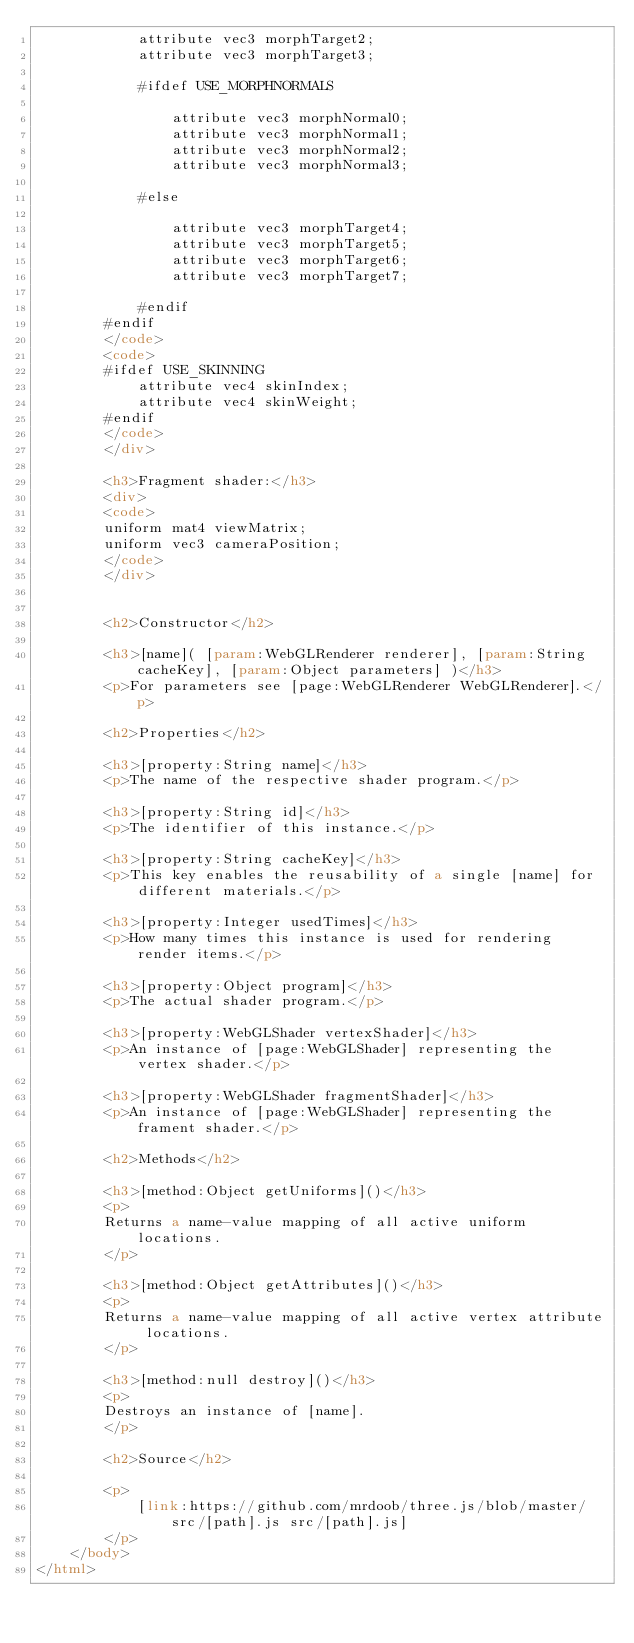<code> <loc_0><loc_0><loc_500><loc_500><_HTML_>			attribute vec3 morphTarget2;
			attribute vec3 morphTarget3;

			#ifdef USE_MORPHNORMALS

				attribute vec3 morphNormal0;
				attribute vec3 morphNormal1;
				attribute vec3 morphNormal2;
				attribute vec3 morphNormal3;

			#else

				attribute vec3 morphTarget4;
				attribute vec3 morphTarget5;
				attribute vec3 morphTarget6;
				attribute vec3 morphTarget7;

			#endif
		#endif
		</code>
		<code>
		#ifdef USE_SKINNING
			attribute vec4 skinIndex;
			attribute vec4 skinWeight;
		#endif
		</code>
		</div>

		<h3>Fragment shader:</h3>
		<div>
		<code>
		uniform mat4 viewMatrix;
		uniform vec3 cameraPosition;
		</code>
		</div>


		<h2>Constructor</h2>

		<h3>[name]( [param:WebGLRenderer renderer], [param:String cacheKey], [param:Object parameters] )</h3>
		<p>For parameters see [page:WebGLRenderer WebGLRenderer].</p>

		<h2>Properties</h2>

		<h3>[property:String name]</h3>
		<p>The name of the respective shader program.</p>

		<h3>[property:String id]</h3>
		<p>The identifier of this instance.</p>

		<h3>[property:String cacheKey]</h3>
		<p>This key enables the reusability of a single [name] for different materials.</p>

		<h3>[property:Integer usedTimes]</h3>
		<p>How many times this instance is used for rendering render items.</p>

		<h3>[property:Object program]</h3>
		<p>The actual shader program.</p>

		<h3>[property:WebGLShader vertexShader]</h3>
		<p>An instance of [page:WebGLShader] representing the vertex shader.</p>

		<h3>[property:WebGLShader fragmentShader]</h3>
		<p>An instance of [page:WebGLShader] representing the frament shader.</p>

		<h2>Methods</h2>

		<h3>[method:Object getUniforms]()</h3>
		<p>
		Returns a name-value mapping of all active uniform locations.
		</p>

		<h3>[method:Object getAttributes]()</h3>
		<p>
		Returns a name-value mapping of all active vertex attribute locations.
		</p>

		<h3>[method:null destroy]()</h3>
		<p>
		Destroys an instance of [name].
		</p>

		<h2>Source</h2>

		<p>
			[link:https://github.com/mrdoob/three.js/blob/master/src/[path].js src/[path].js]
		</p>
	</body>
</html>
</code> 